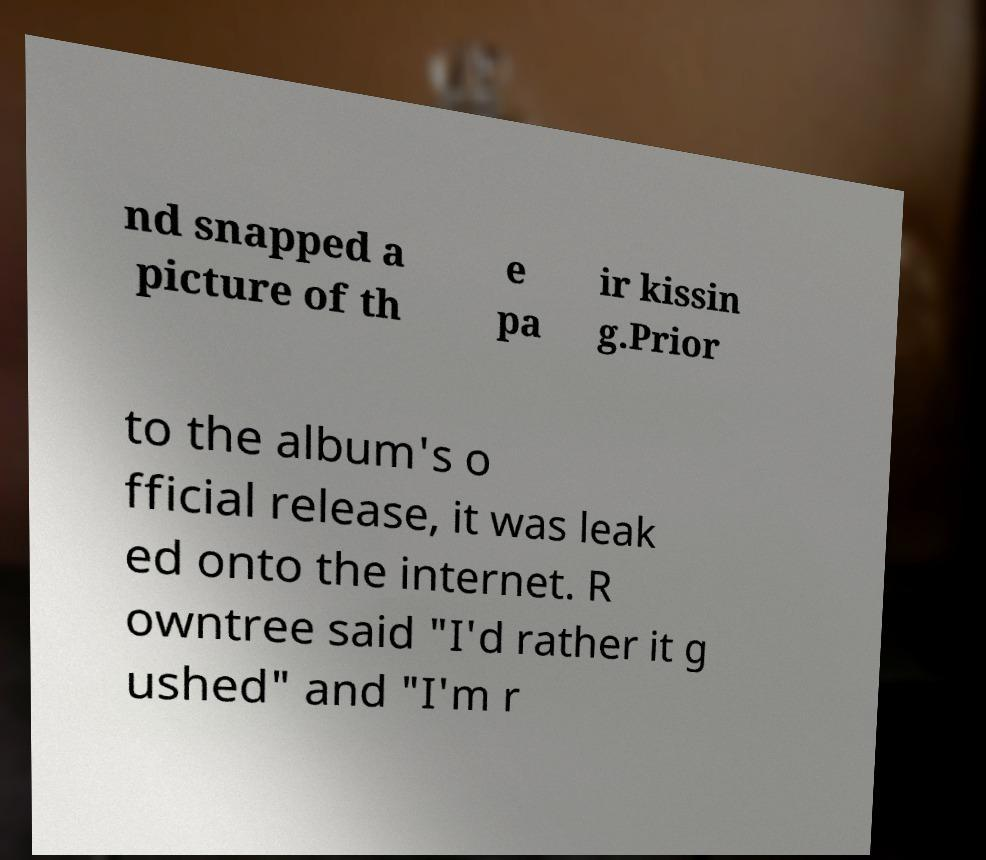Can you read and provide the text displayed in the image?This photo seems to have some interesting text. Can you extract and type it out for me? nd snapped a picture of th e pa ir kissin g.Prior to the album's o fficial release, it was leak ed onto the internet. R owntree said "I'd rather it g ushed" and "I'm r 